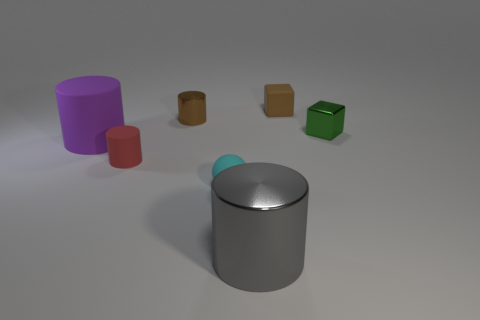If these objects were real, what materials could they be made of based on their appearance? Based on their appearance, the objects could be made from various materials. The cylinders and cube appear to have a matte finish, suggesting they could be made from painted metal or plastic. The large gray cylinder has a shiny, reflective surface, which could indicate that it is made from polished metal. Finally, the small metallic ball has a highly reflective surface that might imply it is made from polished metal or chrome. 